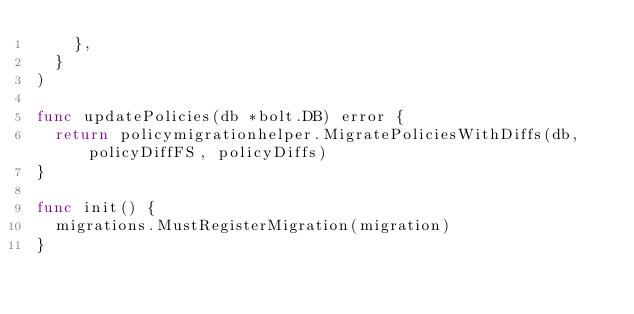<code> <loc_0><loc_0><loc_500><loc_500><_Go_>		},
	}
)

func updatePolicies(db *bolt.DB) error {
	return policymigrationhelper.MigratePoliciesWithDiffs(db, policyDiffFS, policyDiffs)
}

func init() {
	migrations.MustRegisterMigration(migration)
}
</code> 